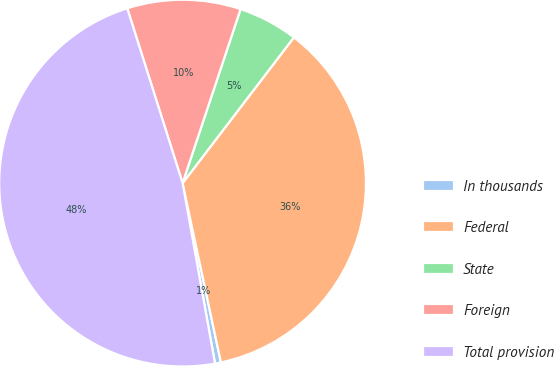Convert chart. <chart><loc_0><loc_0><loc_500><loc_500><pie_chart><fcel>In thousands<fcel>Federal<fcel>State<fcel>Foreign<fcel>Total provision<nl><fcel>0.52%<fcel>36.27%<fcel>5.26%<fcel>10.0%<fcel>47.95%<nl></chart> 